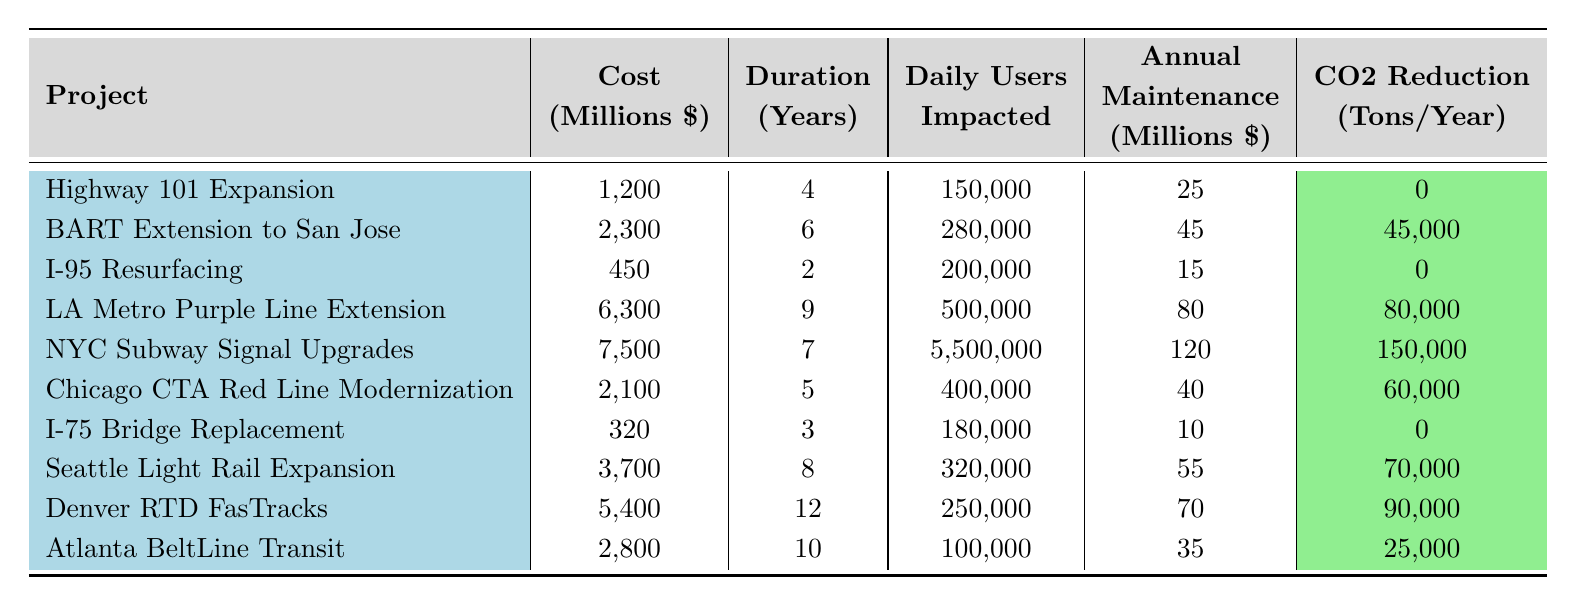What is the cost of the NYC Subway Signal Upgrades project? The cost of the NYC Subway Signal Upgrades project is listed in the table under the "Cost" column, which shows 7,500 million dollars.
Answer: 7500 million dollars Which project has the highest daily users impacted? The table shows the "Daily Users Impacted" for each project, with the NYC Subway Signal Upgrades impacting 5,500,000 users, which is the highest value in that column.
Answer: 5,500,000 What is the total cost of all public transit expansion projects? Summing the costs of the public transit projects, which are BART Extension to San Jose (2,300), LA Metro Purple Line Extension (6,300), Chicago CTA Red Line Modernization (2,100), Seattle Light Rail Expansion (3,700), Denver RTD FasTracks (5,400), and Atlanta BeltLine Transit (2,800) gives: 2,300 + 6,300 + 2,100 + 3,700 + 5,400 + 2,800 = 22,600 million dollars.
Answer: 22,600 million dollars What is the difference in duration between the longest and shortest projects? The longest project is Denver RTD FasTracks at 12 years, and the shortest is I-95 Resurfacing at 2 years. The difference is: 12 - 2 = 10 years.
Answer: 10 years Which project has the highest CO2 reduction and how much is it? Looking at the "CO2 Reduction" column, the NYC Subway Signal Upgrades have the highest CO2 reduction of 150,000 tons per year.
Answer: 150,000 tons per year If we consider annual maintenance costs, which project has the least? The table shows that the I-75 Bridge Replacement has an annual maintenance cost of 10 million dollars, which is the lowest in that column.
Answer: 10 million dollars How many more daily users are impacted by the LA Metro Purple Line Extension compared to I-75 Bridge Replacement? The LA Metro Purple Line Extension affects 500,000 daily users, while I-75 Bridge Replacement affects 180,000 daily users. The difference is: 500,000 - 180,000 = 320,000.
Answer: 320,000 Is the cost per daily user higher for BART Extension to San Jose than for Highway 101 Expansion? To find the cost per daily user, divide each project's cost by its impacted users. For BART, it's 2,300 million / 280,000 = 8.21 million per user, and for Highway 101, it's 1,200 million / 150,000 = 8 million per user. Since 8.21 million > 8 million, the cost per daily user is higher for BART.
Answer: Yes Which project has a duration of more than 8 years and what is the cost? The projects with a duration of more than 8 years are the LA Metro Purple Line Extension (9 years costing 6300 million) and Denver RTD FasTracks (12 years costing 5400 million). The cost of the LA Metro Purple Line Extension is 6300 million.
Answer: 6300 million What is the average annual maintenance cost of all the projects? The annual maintenance costs are: 25, 45, 15, 80, 120, 40, 10, 55, 70, 35. Adding them gives 25 + 45 + 15 + 80 + 120 + 40 + 10 + 55 + 70 + 35 =  490 million. Dividing this sum by the number of projects (10) gives an average maintenance cost of 49 million dollars.
Answer: 49 million dollars 